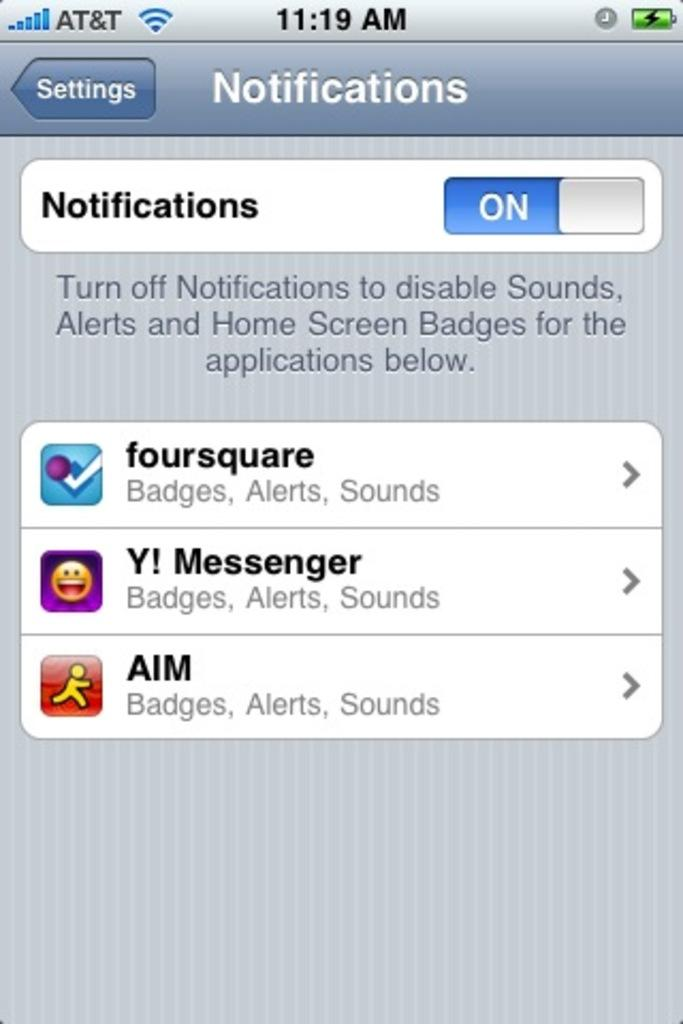<image>
Present a compact description of the photo's key features. The screen shown currently has three notifications one being AIM Badges, Alerts, Sound. 